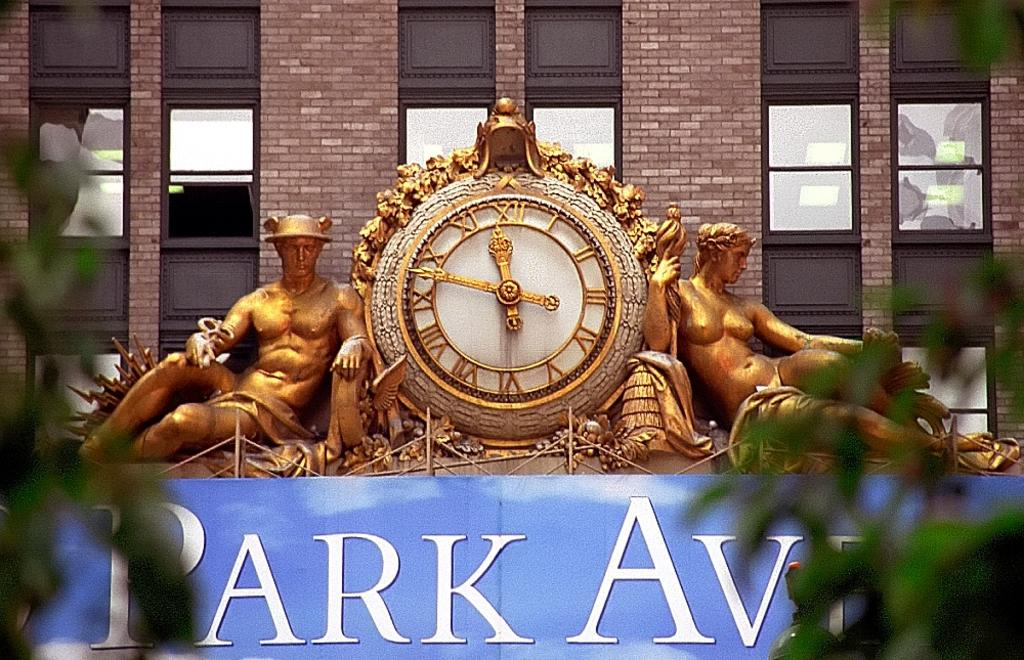<image>
Offer a succinct explanation of the picture presented. A Park Ave sign with a clock between two bronze statues. 